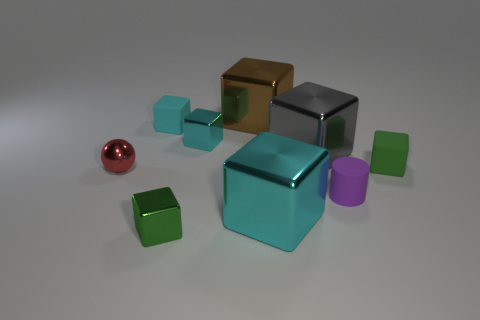Is the number of large cyan blocks to the right of the small shiny ball greater than the number of gray cylinders?
Provide a short and direct response. Yes. There is a red sphere that is the same size as the purple rubber cylinder; what is it made of?
Ensure brevity in your answer.  Metal. Is there a cylinder of the same size as the red metal ball?
Make the answer very short. Yes. What size is the green thing in front of the red sphere?
Ensure brevity in your answer.  Small. How big is the brown block?
Give a very brief answer. Large. How many cylinders are matte things or small purple things?
Your response must be concise. 1. What size is the gray cube that is the same material as the ball?
Provide a short and direct response. Large. How many shiny things have the same color as the small sphere?
Keep it short and to the point. 0. There is a small purple cylinder; are there any cyan cubes behind it?
Provide a succinct answer. Yes. Is the shape of the brown object the same as the tiny cyan thing that is in front of the small cyan matte block?
Offer a very short reply. Yes. 